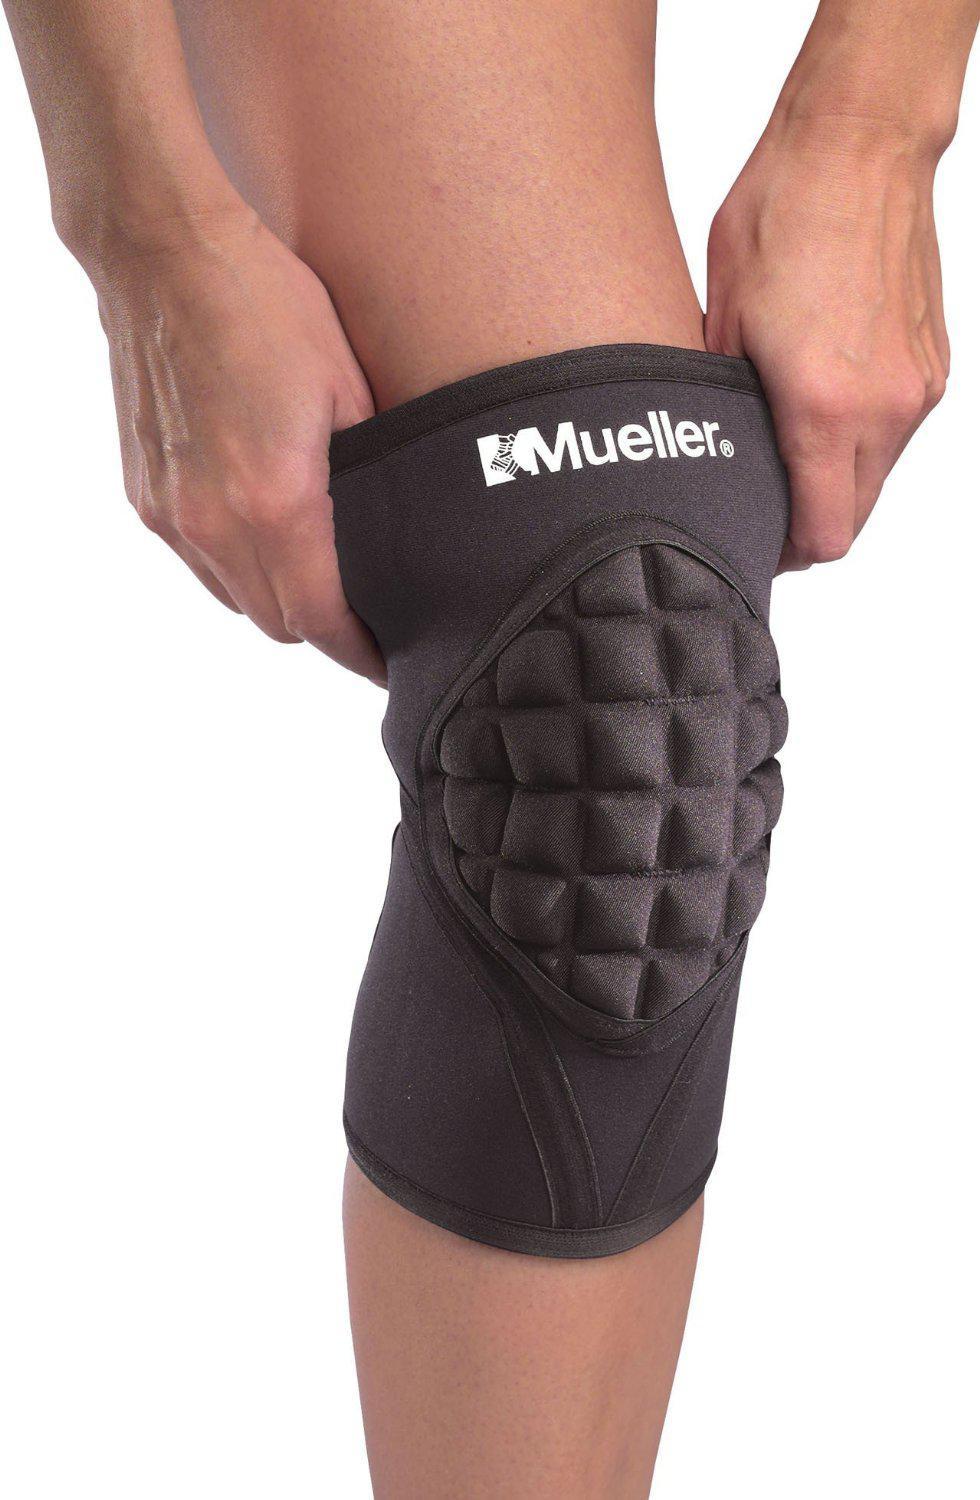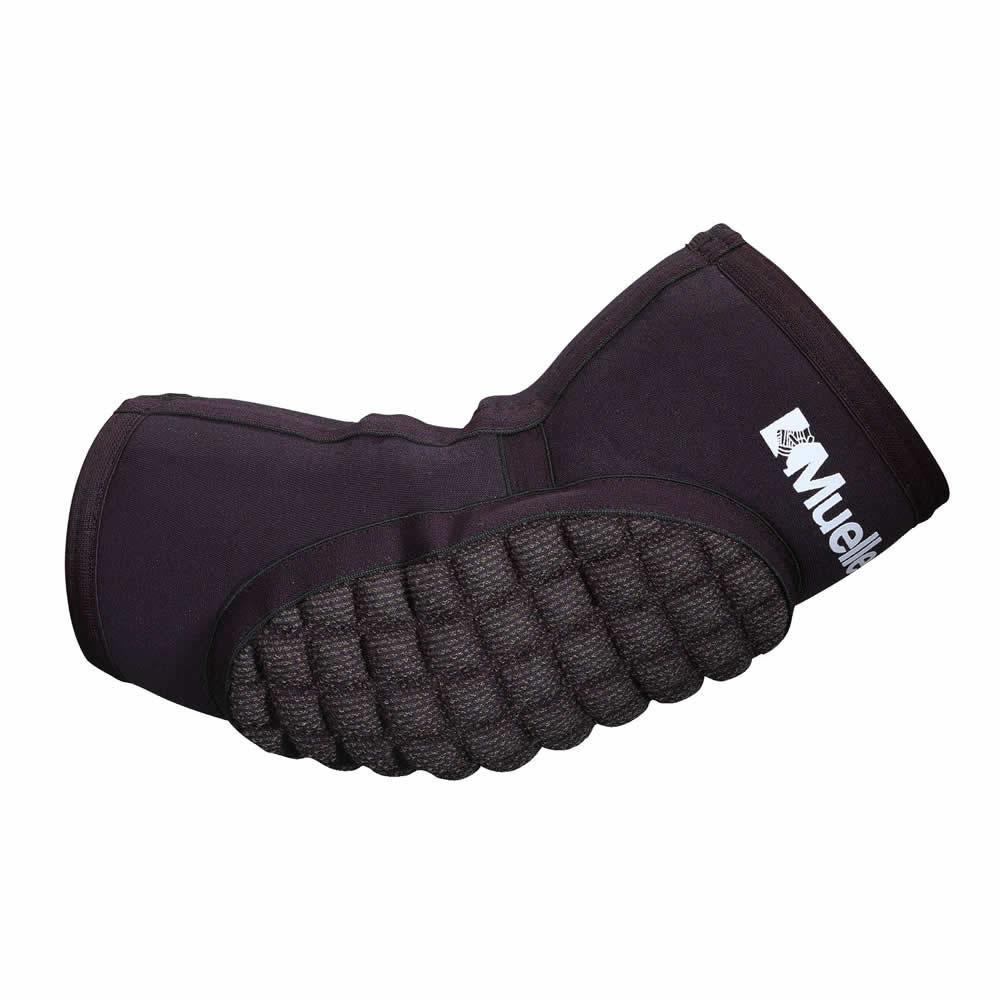The first image is the image on the left, the second image is the image on the right. Assess this claim about the two images: "The pads are demonstrated on at least one leg.". Correct or not? Answer yes or no. Yes. 